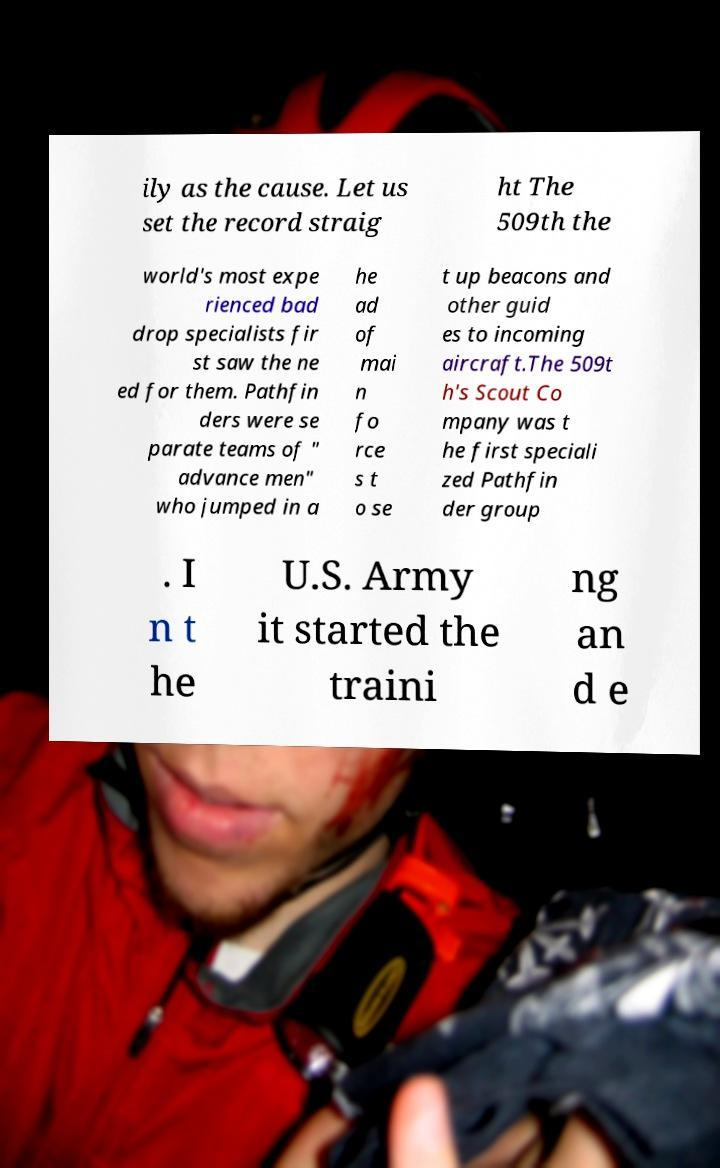Can you accurately transcribe the text from the provided image for me? ily as the cause. Let us set the record straig ht The 509th the world's most expe rienced bad drop specialists fir st saw the ne ed for them. Pathfin ders were se parate teams of " advance men" who jumped in a he ad of mai n fo rce s t o se t up beacons and other guid es to incoming aircraft.The 509t h's Scout Co mpany was t he first speciali zed Pathfin der group . I n t he U.S. Army it started the traini ng an d e 